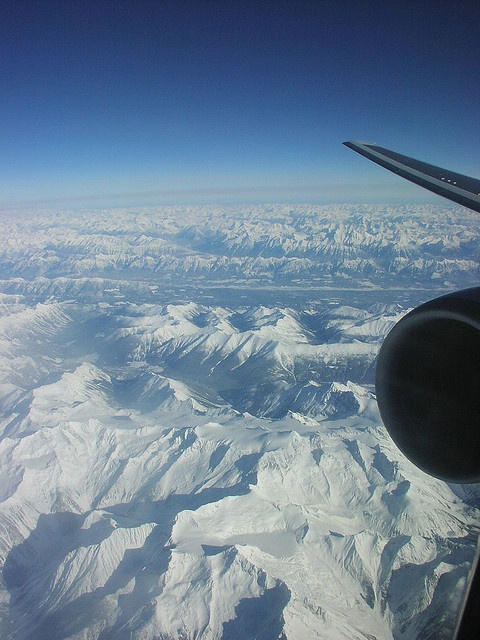Describe the objects in this image and their specific colors. I can see a airplane in navy, black, gray, darkblue, and blue tones in this image. 